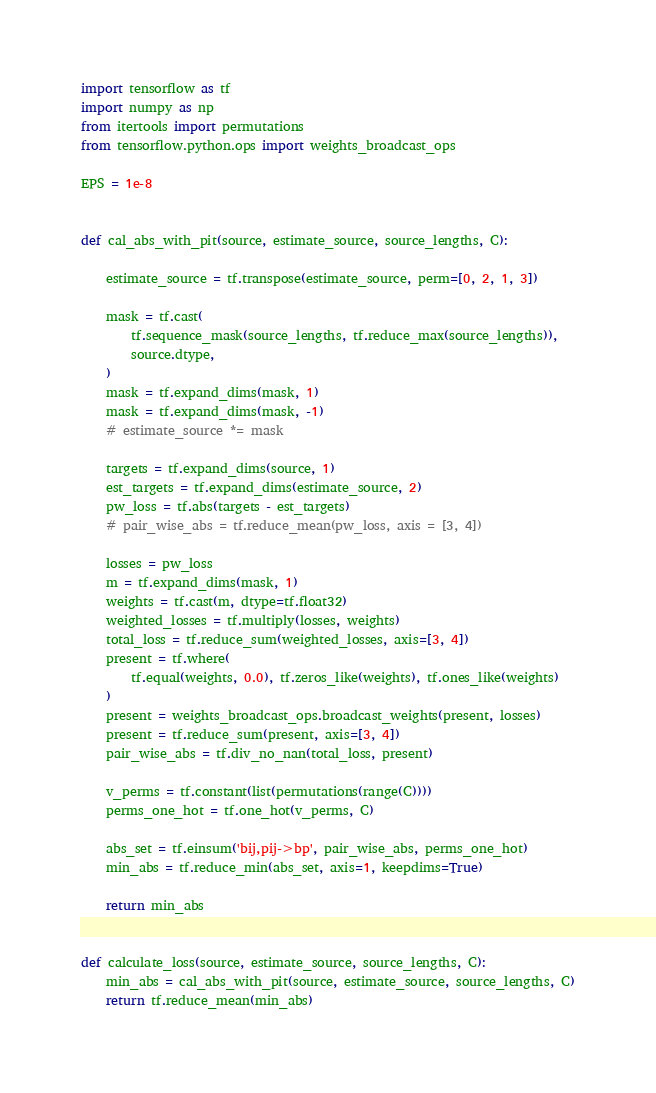Convert code to text. <code><loc_0><loc_0><loc_500><loc_500><_Python_>import tensorflow as tf
import numpy as np
from itertools import permutations
from tensorflow.python.ops import weights_broadcast_ops

EPS = 1e-8


def cal_abs_with_pit(source, estimate_source, source_lengths, C):

    estimate_source = tf.transpose(estimate_source, perm=[0, 2, 1, 3])

    mask = tf.cast(
        tf.sequence_mask(source_lengths, tf.reduce_max(source_lengths)),
        source.dtype,
    )
    mask = tf.expand_dims(mask, 1)
    mask = tf.expand_dims(mask, -1)
    # estimate_source *= mask

    targets = tf.expand_dims(source, 1)
    est_targets = tf.expand_dims(estimate_source, 2)
    pw_loss = tf.abs(targets - est_targets)
    # pair_wise_abs = tf.reduce_mean(pw_loss, axis = [3, 4])

    losses = pw_loss
    m = tf.expand_dims(mask, 1)
    weights = tf.cast(m, dtype=tf.float32)
    weighted_losses = tf.multiply(losses, weights)
    total_loss = tf.reduce_sum(weighted_losses, axis=[3, 4])
    present = tf.where(
        tf.equal(weights, 0.0), tf.zeros_like(weights), tf.ones_like(weights)
    )
    present = weights_broadcast_ops.broadcast_weights(present, losses)
    present = tf.reduce_sum(present, axis=[3, 4])
    pair_wise_abs = tf.div_no_nan(total_loss, present)

    v_perms = tf.constant(list(permutations(range(C))))
    perms_one_hot = tf.one_hot(v_perms, C)

    abs_set = tf.einsum('bij,pij->bp', pair_wise_abs, perms_one_hot)
    min_abs = tf.reduce_min(abs_set, axis=1, keepdims=True)

    return min_abs


def calculate_loss(source, estimate_source, source_lengths, C):
    min_abs = cal_abs_with_pit(source, estimate_source, source_lengths, C)
    return tf.reduce_mean(min_abs)
</code> 